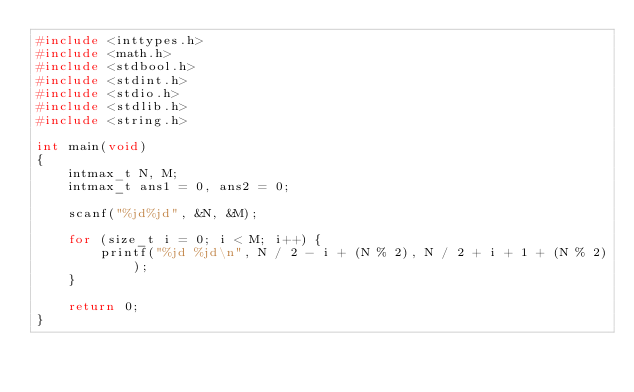Convert code to text. <code><loc_0><loc_0><loc_500><loc_500><_C_>#include <inttypes.h>
#include <math.h>
#include <stdbool.h>
#include <stdint.h>
#include <stdio.h>
#include <stdlib.h>
#include <string.h>

int main(void)
{
    intmax_t N, M;
    intmax_t ans1 = 0, ans2 = 0;

    scanf("%jd%jd", &N, &M);

    for (size_t i = 0; i < M; i++) {
        printf("%jd %jd\n", N / 2 - i + (N % 2), N / 2 + i + 1 + (N % 2));
    }

    return 0;
}
</code> 